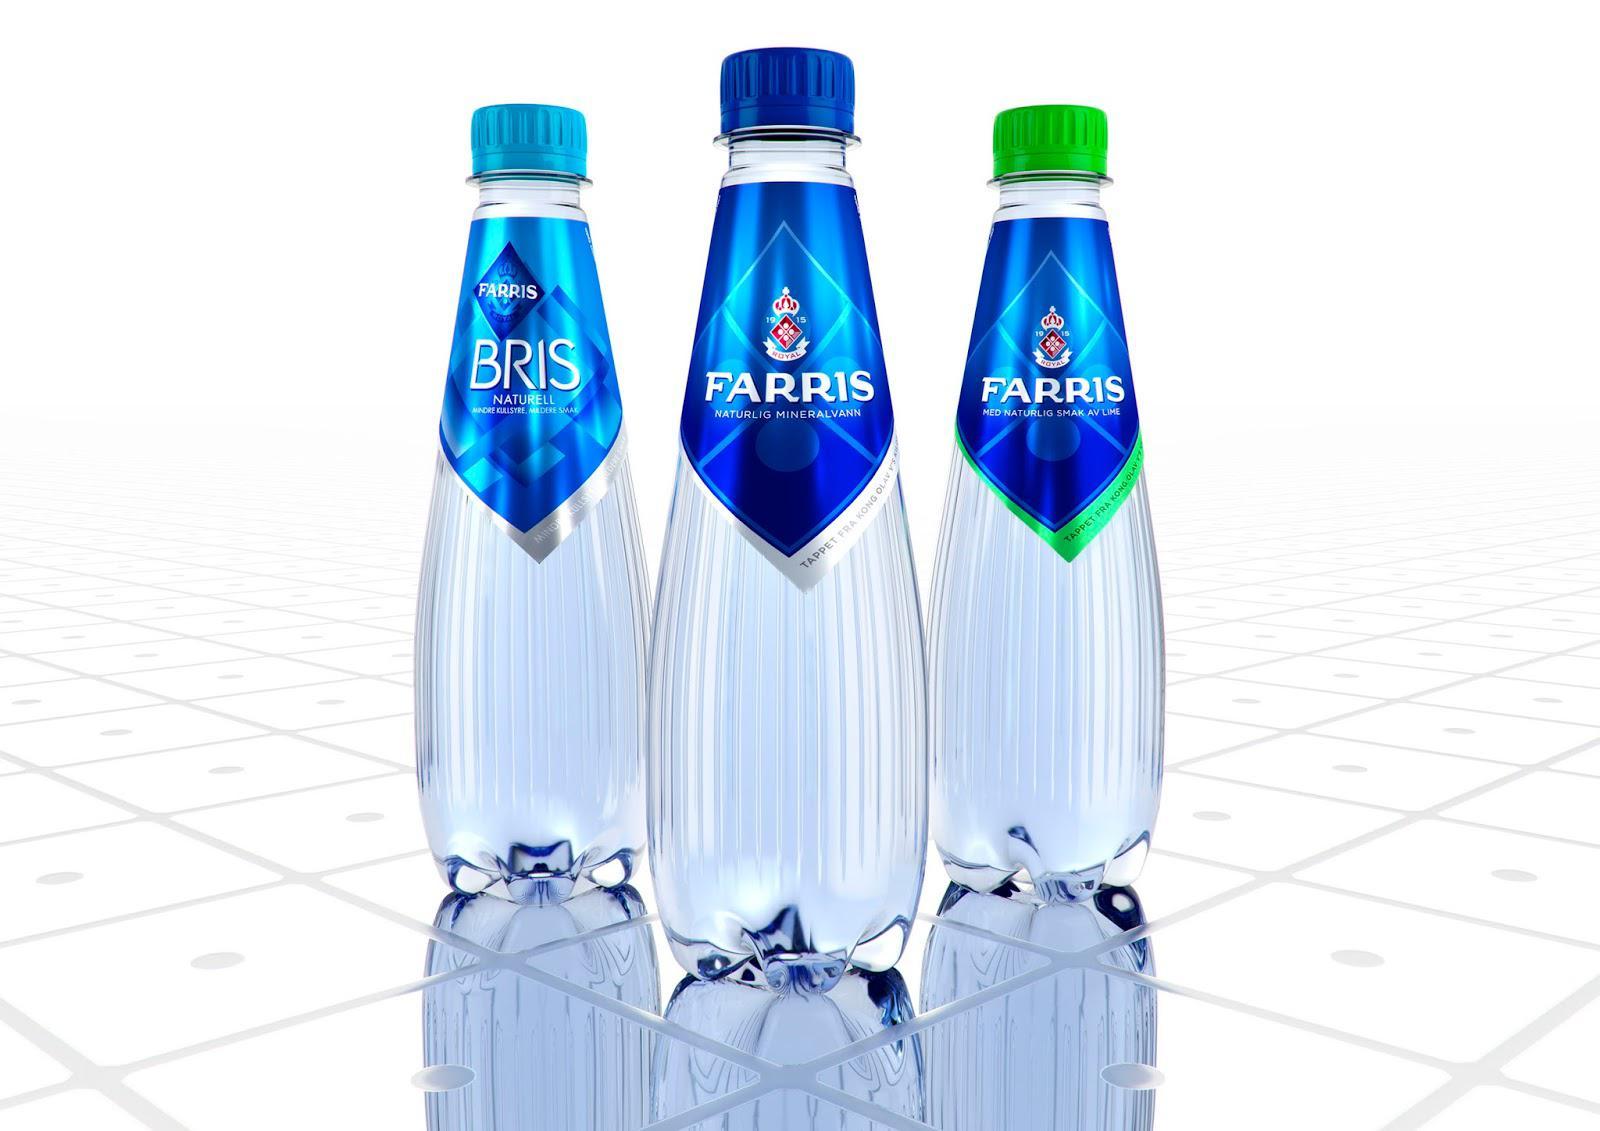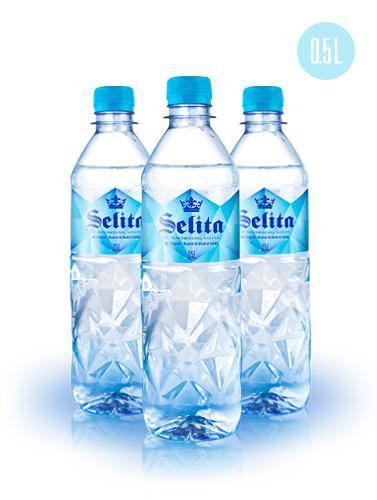The first image is the image on the left, the second image is the image on the right. For the images shown, is this caption "All bottles are upright and have lids on them, and at least some bottles have visible labels." true? Answer yes or no. Yes. The first image is the image on the left, the second image is the image on the right. Examine the images to the left and right. Is the description "In at least one image there are three single person sealed water bottles." accurate? Answer yes or no. Yes. 